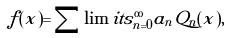Convert formula to latex. <formula><loc_0><loc_0><loc_500><loc_500>f ( x ) = \sum \lim i t s _ { n = 0 } ^ { \infty } a _ { n } Q _ { n } ( x ) ,</formula> 